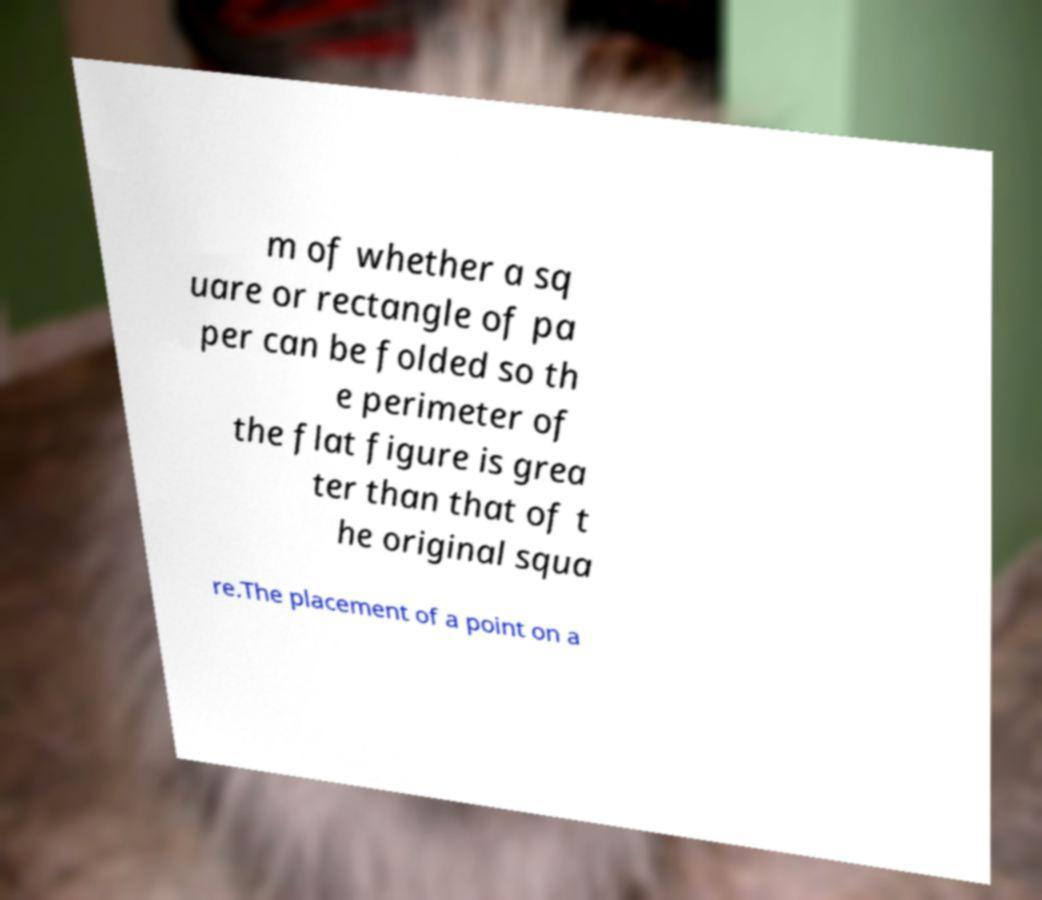Can you read and provide the text displayed in the image?This photo seems to have some interesting text. Can you extract and type it out for me? m of whether a sq uare or rectangle of pa per can be folded so th e perimeter of the flat figure is grea ter than that of t he original squa re.The placement of a point on a 